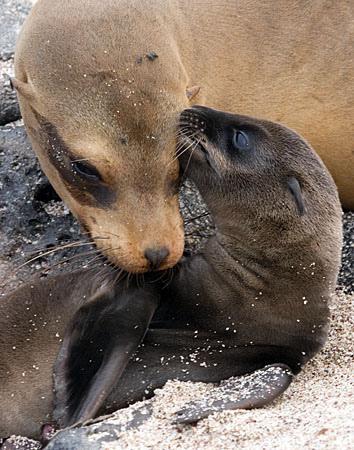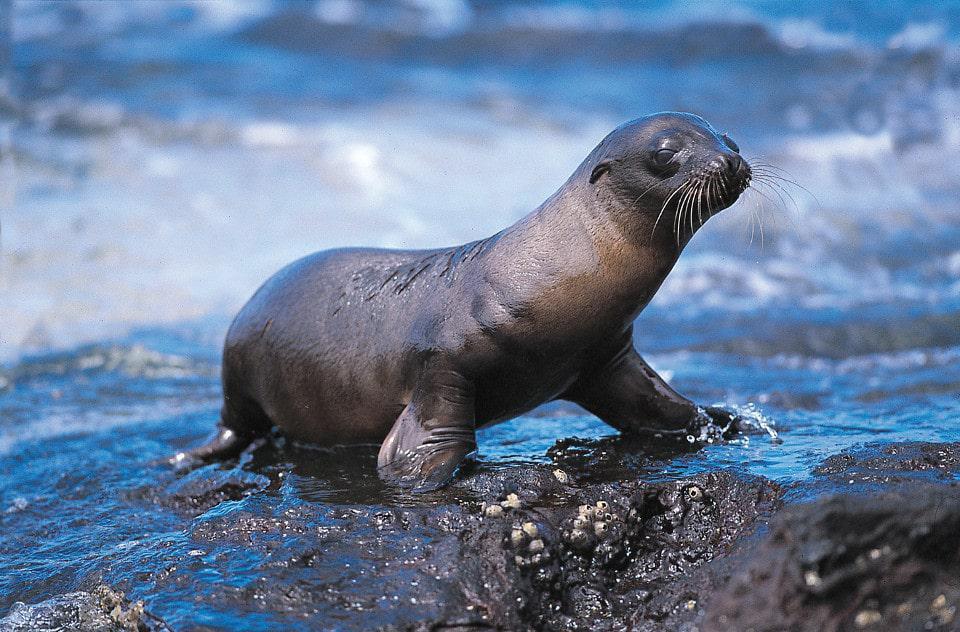The first image is the image on the left, the second image is the image on the right. Analyze the images presented: Is the assertion "Two seals are on a sandy surface in the image on the left." valid? Answer yes or no. Yes. The first image is the image on the left, the second image is the image on the right. Evaluate the accuracy of this statement regarding the images: "Each image shows one seal in the foreground, and all foreground seals are babies with their heads rightside-up instead of upside-down.". Is it true? Answer yes or no. No. 